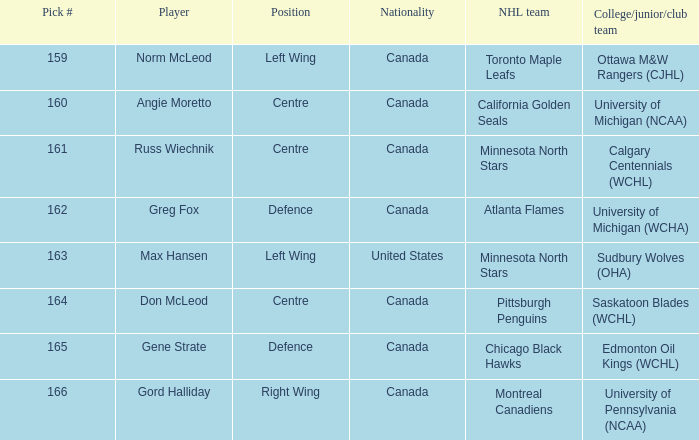What is the nationality of the player from the University of Michigan (NCAA)? Canada. 